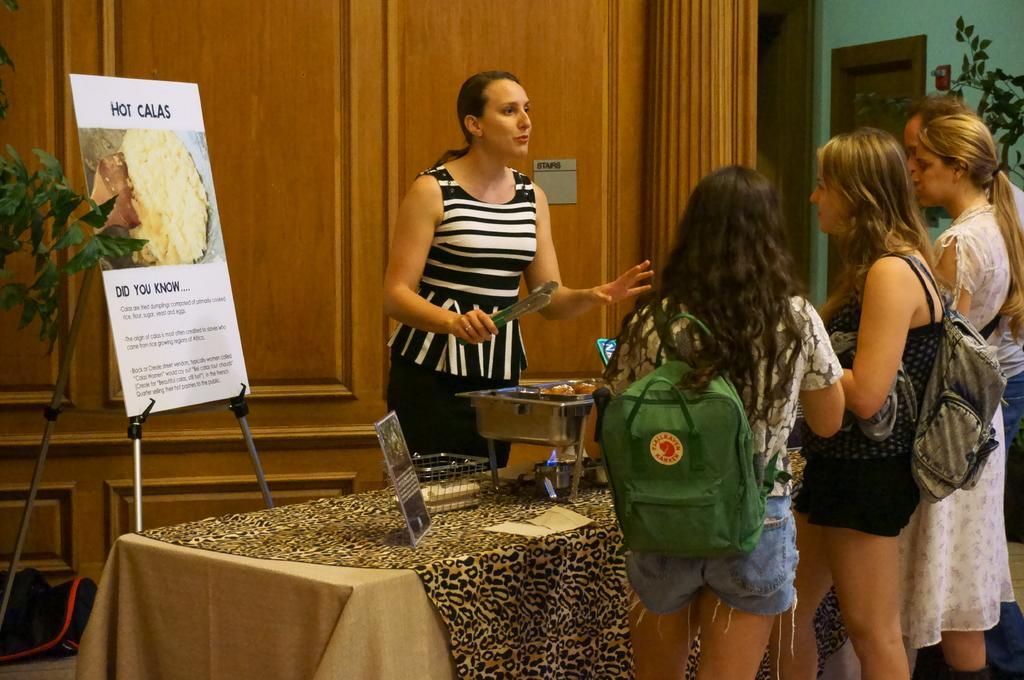Please provide a concise description of this image. In this image there are four persons standing besides a table towards the right. These two women are wearing bags. Before them there is another woman wearing striped dress and holding a tongs. On the table there is a stove, a frame and a dish. Towards the left there is a board and a plant, on the board, some text printed on it. In the background there is a wood wall. 